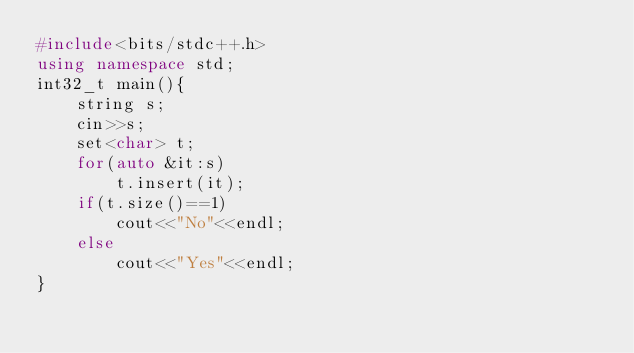Convert code to text. <code><loc_0><loc_0><loc_500><loc_500><_C++_>#include<bits/stdc++.h>
using namespace std;
int32_t main(){
	string s;
	cin>>s; 
	set<char> t; 
	for(auto &it:s)
		t.insert(it); 
	if(t.size()==1)
		cout<<"No"<<endl; 
	else 
		cout<<"Yes"<<endl;
}</code> 